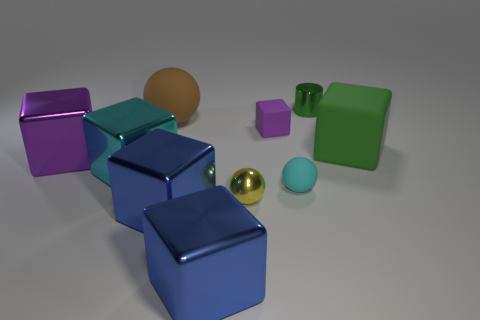Subtract all small cubes. How many cubes are left? 5 Subtract all green cubes. How many cubes are left? 5 Subtract all green blocks. Subtract all red cylinders. How many blocks are left? 5 Subtract all cylinders. How many objects are left? 9 Add 2 large objects. How many large objects are left? 8 Add 8 tiny cyan metal spheres. How many tiny cyan metal spheres exist? 8 Subtract 0 red spheres. How many objects are left? 10 Subtract all metal blocks. Subtract all cyan spheres. How many objects are left? 5 